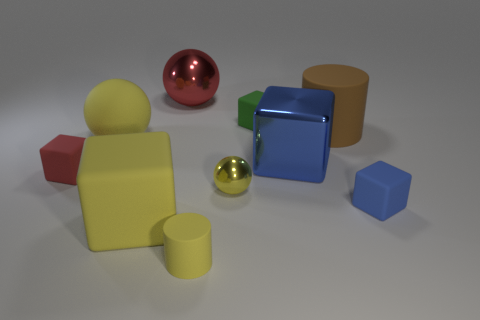Is the material of the red ball the same as the large yellow sphere?
Offer a terse response. No. What number of balls are matte things or brown objects?
Provide a succinct answer. 1. There is a blue rubber cube right of the large matte thing that is to the left of the big object in front of the tiny red rubber cube; what size is it?
Keep it short and to the point. Small. The yellow rubber object that is the same shape as the red metal thing is what size?
Your answer should be very brief. Large. What number of blue rubber things are behind the big yellow matte cube?
Ensure brevity in your answer.  1. There is a rubber cylinder that is on the left side of the yellow shiny sphere; does it have the same color as the big matte block?
Give a very brief answer. Yes. What number of blue objects are tiny rubber cubes or small metallic spheres?
Ensure brevity in your answer.  1. There is a ball that is on the right side of the yellow cylinder in front of the large rubber ball; what is its color?
Provide a short and direct response. Yellow. There is a cylinder that is the same color as the tiny sphere; what material is it?
Your response must be concise. Rubber. The tiny matte block that is on the left side of the yellow cylinder is what color?
Keep it short and to the point. Red. 